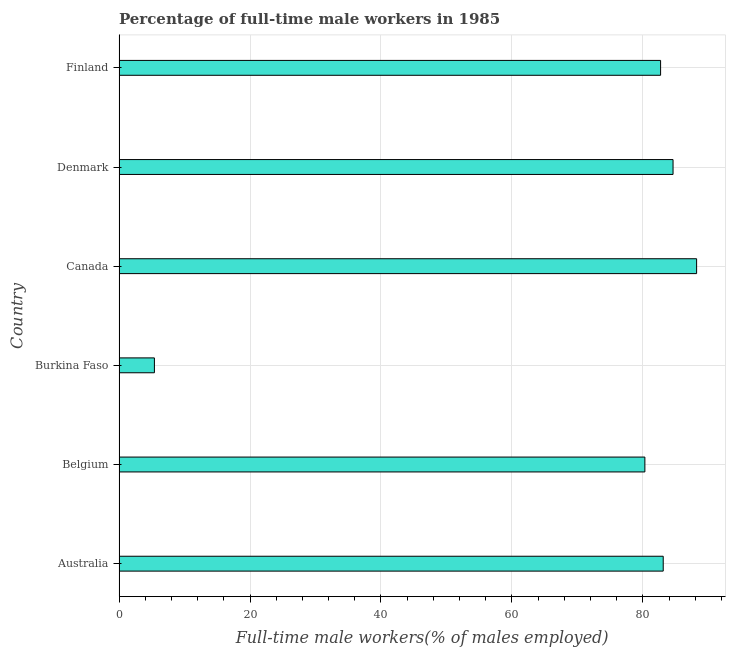Does the graph contain any zero values?
Make the answer very short. No. Does the graph contain grids?
Offer a terse response. Yes. What is the title of the graph?
Your response must be concise. Percentage of full-time male workers in 1985. What is the label or title of the X-axis?
Keep it short and to the point. Full-time male workers(% of males employed). What is the label or title of the Y-axis?
Offer a very short reply. Country. What is the percentage of full-time male workers in Denmark?
Give a very brief answer. 84.6. Across all countries, what is the maximum percentage of full-time male workers?
Your answer should be very brief. 88.2. Across all countries, what is the minimum percentage of full-time male workers?
Make the answer very short. 5.4. In which country was the percentage of full-time male workers minimum?
Give a very brief answer. Burkina Faso. What is the sum of the percentage of full-time male workers?
Provide a short and direct response. 424.3. What is the difference between the percentage of full-time male workers in Australia and Denmark?
Ensure brevity in your answer.  -1.5. What is the average percentage of full-time male workers per country?
Give a very brief answer. 70.72. What is the median percentage of full-time male workers?
Give a very brief answer. 82.9. What is the ratio of the percentage of full-time male workers in Australia to that in Burkina Faso?
Your response must be concise. 15.39. Is the difference between the percentage of full-time male workers in Burkina Faso and Canada greater than the difference between any two countries?
Provide a short and direct response. Yes. What is the difference between the highest and the second highest percentage of full-time male workers?
Keep it short and to the point. 3.6. What is the difference between the highest and the lowest percentage of full-time male workers?
Ensure brevity in your answer.  82.8. How many bars are there?
Keep it short and to the point. 6. Are all the bars in the graph horizontal?
Provide a succinct answer. Yes. What is the Full-time male workers(% of males employed) of Australia?
Provide a short and direct response. 83.1. What is the Full-time male workers(% of males employed) in Belgium?
Offer a terse response. 80.3. What is the Full-time male workers(% of males employed) of Burkina Faso?
Give a very brief answer. 5.4. What is the Full-time male workers(% of males employed) in Canada?
Your answer should be compact. 88.2. What is the Full-time male workers(% of males employed) of Denmark?
Provide a short and direct response. 84.6. What is the Full-time male workers(% of males employed) of Finland?
Your answer should be compact. 82.7. What is the difference between the Full-time male workers(% of males employed) in Australia and Belgium?
Your answer should be compact. 2.8. What is the difference between the Full-time male workers(% of males employed) in Australia and Burkina Faso?
Offer a terse response. 77.7. What is the difference between the Full-time male workers(% of males employed) in Australia and Canada?
Provide a short and direct response. -5.1. What is the difference between the Full-time male workers(% of males employed) in Australia and Denmark?
Keep it short and to the point. -1.5. What is the difference between the Full-time male workers(% of males employed) in Belgium and Burkina Faso?
Give a very brief answer. 74.9. What is the difference between the Full-time male workers(% of males employed) in Belgium and Canada?
Provide a short and direct response. -7.9. What is the difference between the Full-time male workers(% of males employed) in Belgium and Denmark?
Your response must be concise. -4.3. What is the difference between the Full-time male workers(% of males employed) in Belgium and Finland?
Make the answer very short. -2.4. What is the difference between the Full-time male workers(% of males employed) in Burkina Faso and Canada?
Ensure brevity in your answer.  -82.8. What is the difference between the Full-time male workers(% of males employed) in Burkina Faso and Denmark?
Your answer should be compact. -79.2. What is the difference between the Full-time male workers(% of males employed) in Burkina Faso and Finland?
Provide a succinct answer. -77.3. What is the difference between the Full-time male workers(% of males employed) in Canada and Denmark?
Offer a terse response. 3.6. What is the difference between the Full-time male workers(% of males employed) in Canada and Finland?
Provide a short and direct response. 5.5. What is the ratio of the Full-time male workers(% of males employed) in Australia to that in Belgium?
Provide a short and direct response. 1.03. What is the ratio of the Full-time male workers(% of males employed) in Australia to that in Burkina Faso?
Your answer should be very brief. 15.39. What is the ratio of the Full-time male workers(% of males employed) in Australia to that in Canada?
Make the answer very short. 0.94. What is the ratio of the Full-time male workers(% of males employed) in Belgium to that in Burkina Faso?
Offer a terse response. 14.87. What is the ratio of the Full-time male workers(% of males employed) in Belgium to that in Canada?
Provide a short and direct response. 0.91. What is the ratio of the Full-time male workers(% of males employed) in Belgium to that in Denmark?
Give a very brief answer. 0.95. What is the ratio of the Full-time male workers(% of males employed) in Burkina Faso to that in Canada?
Offer a very short reply. 0.06. What is the ratio of the Full-time male workers(% of males employed) in Burkina Faso to that in Denmark?
Offer a very short reply. 0.06. What is the ratio of the Full-time male workers(% of males employed) in Burkina Faso to that in Finland?
Your answer should be very brief. 0.07. What is the ratio of the Full-time male workers(% of males employed) in Canada to that in Denmark?
Keep it short and to the point. 1.04. What is the ratio of the Full-time male workers(% of males employed) in Canada to that in Finland?
Provide a short and direct response. 1.07. 